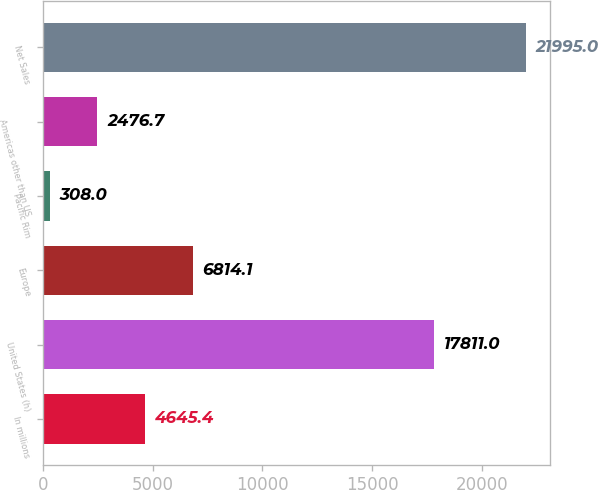<chart> <loc_0><loc_0><loc_500><loc_500><bar_chart><fcel>In millions<fcel>United States (h)<fcel>Europe<fcel>Pacific Rim<fcel>Americas other than US<fcel>Net Sales<nl><fcel>4645.4<fcel>17811<fcel>6814.1<fcel>308<fcel>2476.7<fcel>21995<nl></chart> 